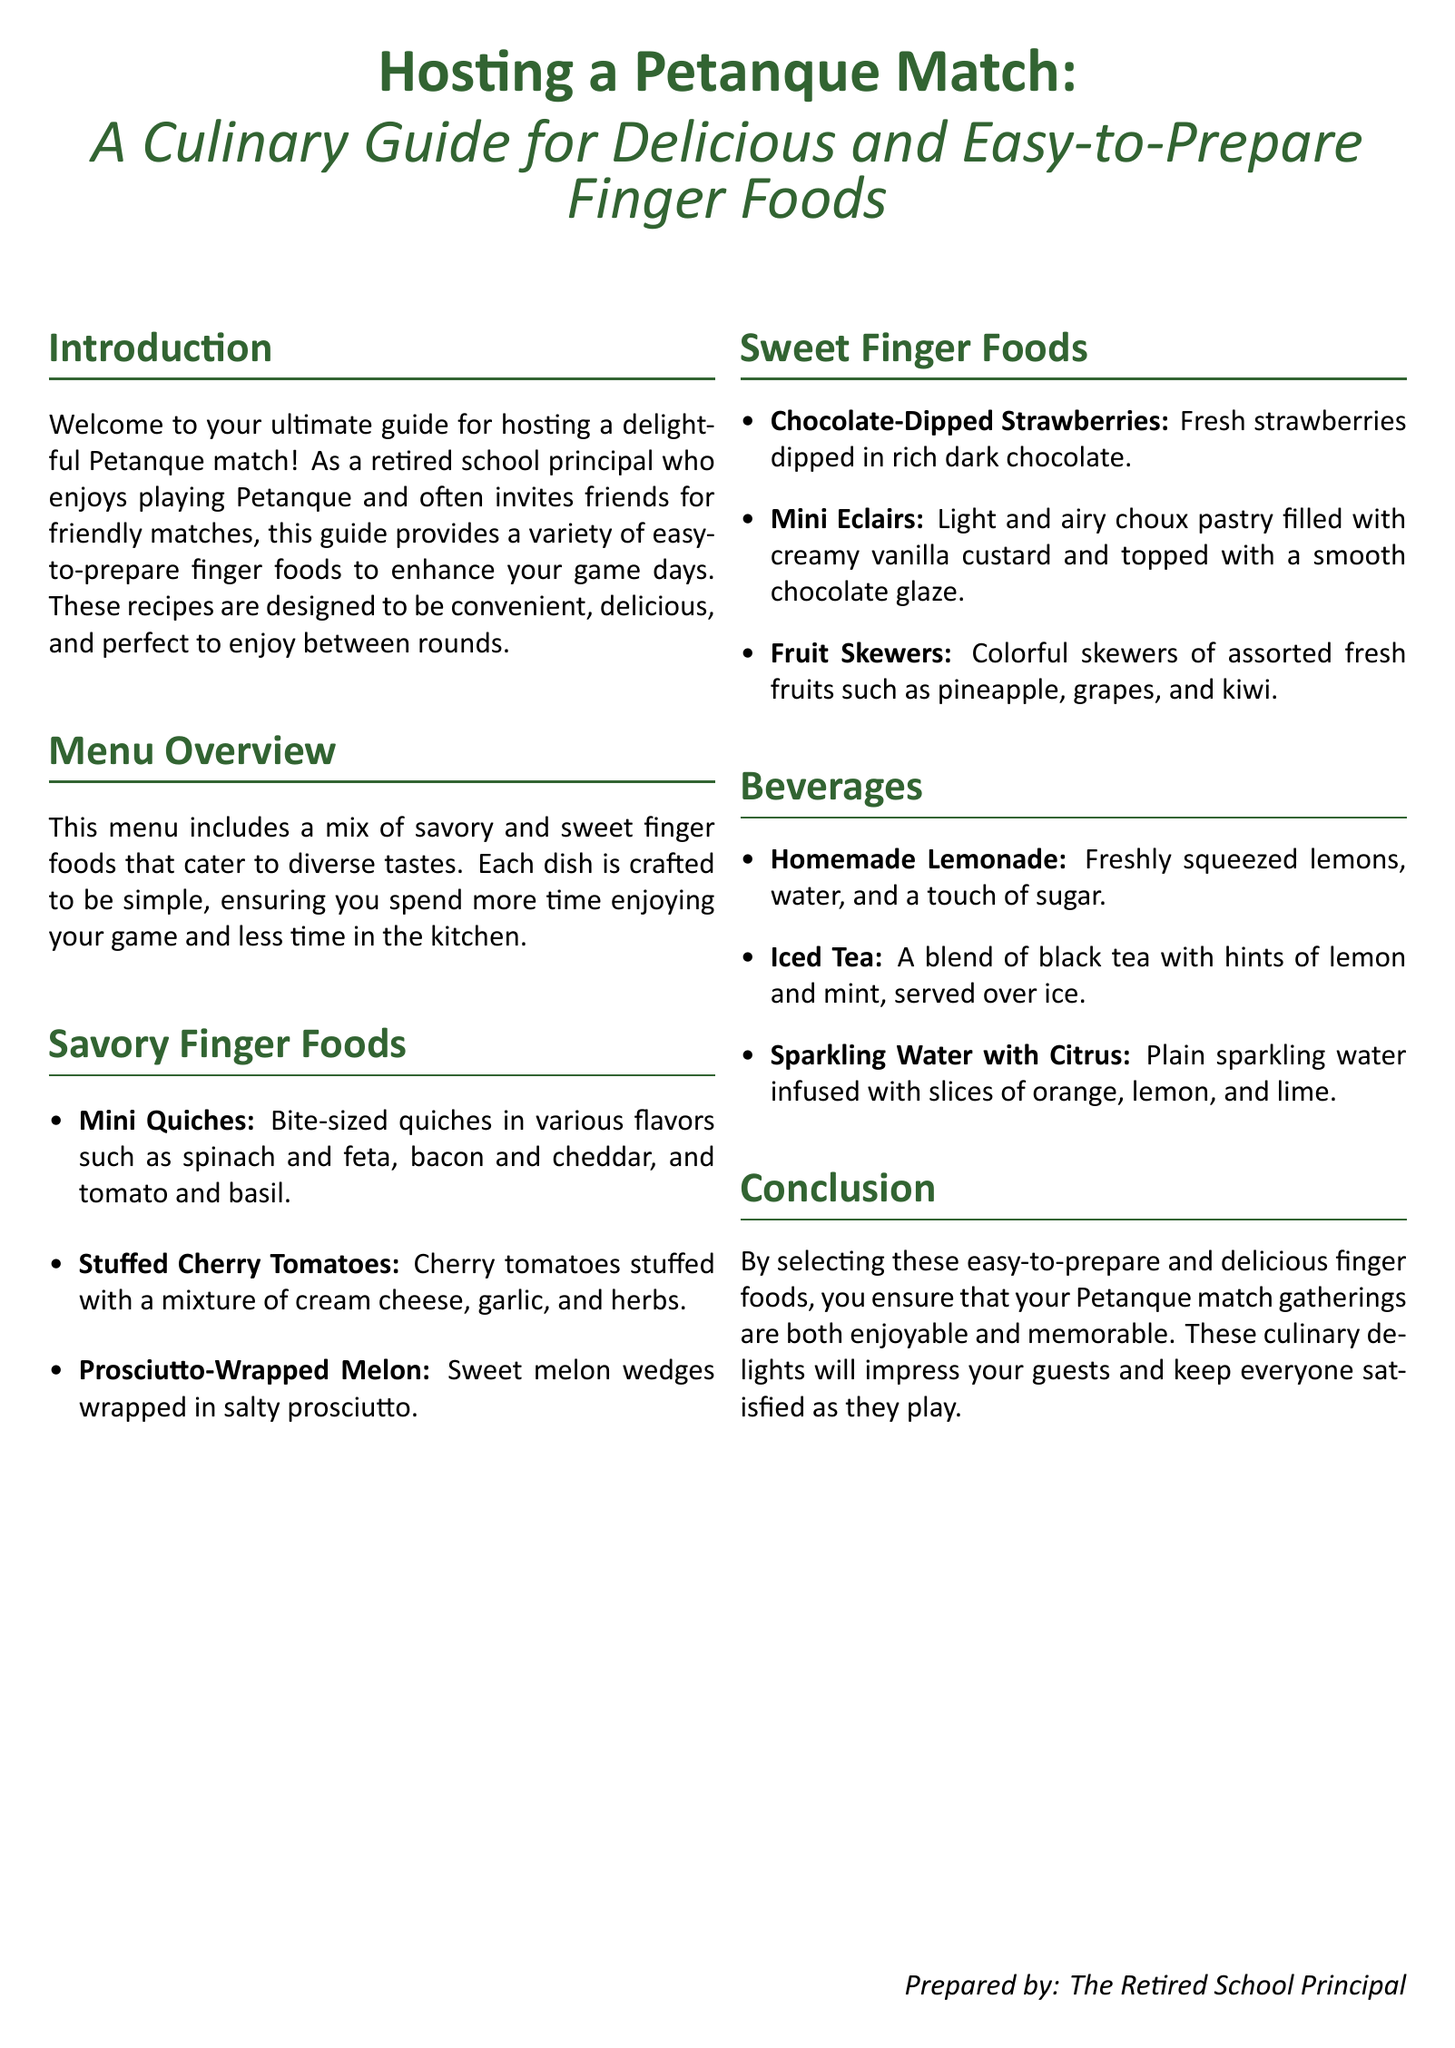What is the main focus of the guide? The main focus of the guide is to provide a culinary guide for delicious and easy-to-prepare finger foods for hosting a Petanque match.
Answer: Culinary guide How many types of finger foods are listed in the document? There are two main categories of finger foods listed: savory and sweet.
Answer: Two Name one savory finger food mentioned. Savory finger foods include options such as mini quiches, stuffed cherry tomatoes, and prosciutto-wrapped melon.
Answer: Mini quiches What beverage is made from freshly squeezed lemons? The beverage made from freshly squeezed lemons is homemade lemonade.
Answer: Homemade lemonade How many sweet finger foods does the document describe? The document describes three sweet finger foods.
Answer: Three What is one of the fruits used in the fruit skewers? The fruit skewers include assorted fresh fruits such as pineapple, grapes, and kiwi.
Answer: Pineapple Which unique dish is highlighted as "bite-sized"? The unique dish highlighted as "bite-sized" is mini quiches.
Answer: Mini quiches Who prepared the document? The document was prepared by "The Retired School Principal."
Answer: The Retired School Principal 